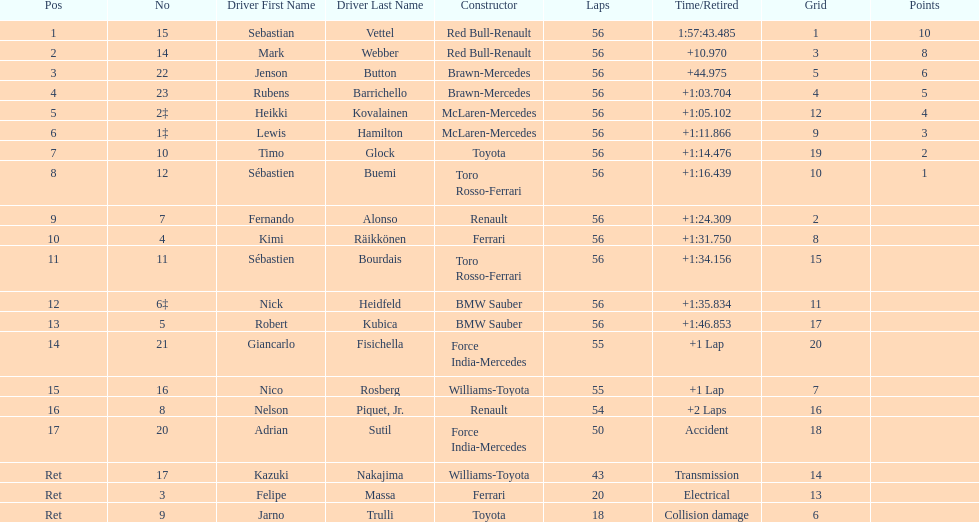What was jenson button's time? +44.975. Parse the full table. {'header': ['Pos', 'No', 'Driver First Name', 'Driver Last Name', 'Constructor', 'Laps', 'Time/Retired', 'Grid', 'Points'], 'rows': [['1', '15', 'Sebastian', 'Vettel', 'Red Bull-Renault', '56', '1:57:43.485', '1', '10'], ['2', '14', 'Mark', 'Webber', 'Red Bull-Renault', '56', '+10.970', '3', '8'], ['3', '22', 'Jenson', 'Button', 'Brawn-Mercedes', '56', '+44.975', '5', '6'], ['4', '23', 'Rubens', 'Barrichello', 'Brawn-Mercedes', '56', '+1:03.704', '4', '5'], ['5', '2‡', 'Heikki', 'Kovalainen', 'McLaren-Mercedes', '56', '+1:05.102', '12', '4'], ['6', '1‡', 'Lewis', 'Hamilton', 'McLaren-Mercedes', '56', '+1:11.866', '9', '3'], ['7', '10', 'Timo', 'Glock', 'Toyota', '56', '+1:14.476', '19', '2'], ['8', '12', 'Sébastien', 'Buemi', 'Toro Rosso-Ferrari', '56', '+1:16.439', '10', '1'], ['9', '7', 'Fernando', 'Alonso', 'Renault', '56', '+1:24.309', '2', ''], ['10', '4', 'Kimi', 'Räikkönen', 'Ferrari', '56', '+1:31.750', '8', ''], ['11', '11', 'Sébastien', 'Bourdais', 'Toro Rosso-Ferrari', '56', '+1:34.156', '15', ''], ['12', '6‡', 'Nick', 'Heidfeld', 'BMW Sauber', '56', '+1:35.834', '11', ''], ['13', '5', 'Robert', 'Kubica', 'BMW Sauber', '56', '+1:46.853', '17', ''], ['14', '21', 'Giancarlo', 'Fisichella', 'Force India-Mercedes', '55', '+1 Lap', '20', ''], ['15', '16', 'Nico', 'Rosberg', 'Williams-Toyota', '55', '+1 Lap', '7', ''], ['16', '8', 'Nelson', 'Piquet, Jr.', 'Renault', '54', '+2 Laps', '16', ''], ['17', '20', 'Adrian', 'Sutil', 'Force India-Mercedes', '50', 'Accident', '18', ''], ['Ret', '17', 'Kazuki', 'Nakajima', 'Williams-Toyota', '43', 'Transmission', '14', ''], ['Ret', '3', 'Felipe', 'Massa', 'Ferrari', '20', 'Electrical', '13', ''], ['Ret', '9', 'Jarno', 'Trulli', 'Toyota', '18', 'Collision damage', '6', '']]} 